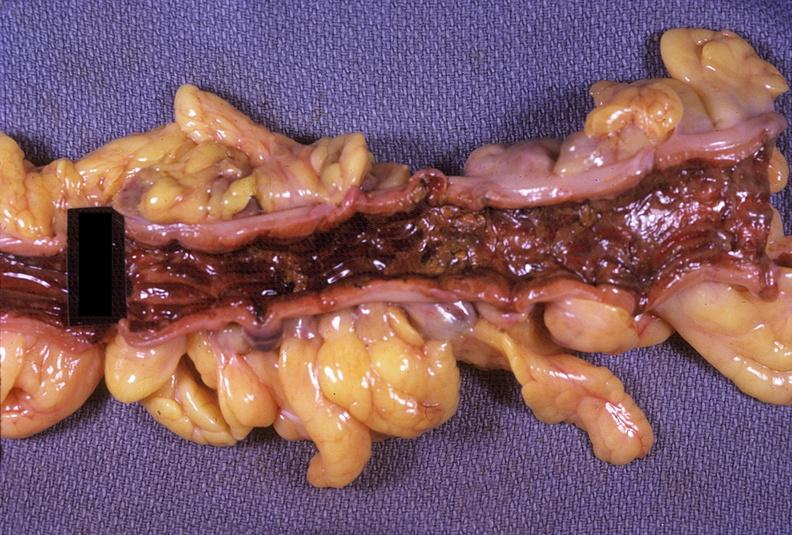where does this belong to?
Answer the question using a single word or phrase. Gastrointestinal system 